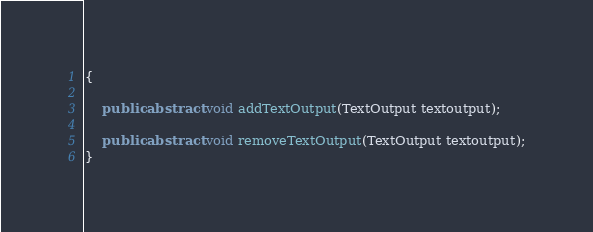Convert code to text. <code><loc_0><loc_0><loc_500><loc_500><_Java_>{

	public abstract void addTextOutput(TextOutput textoutput);

	public abstract void removeTextOutput(TextOutput textoutput);
}
</code> 